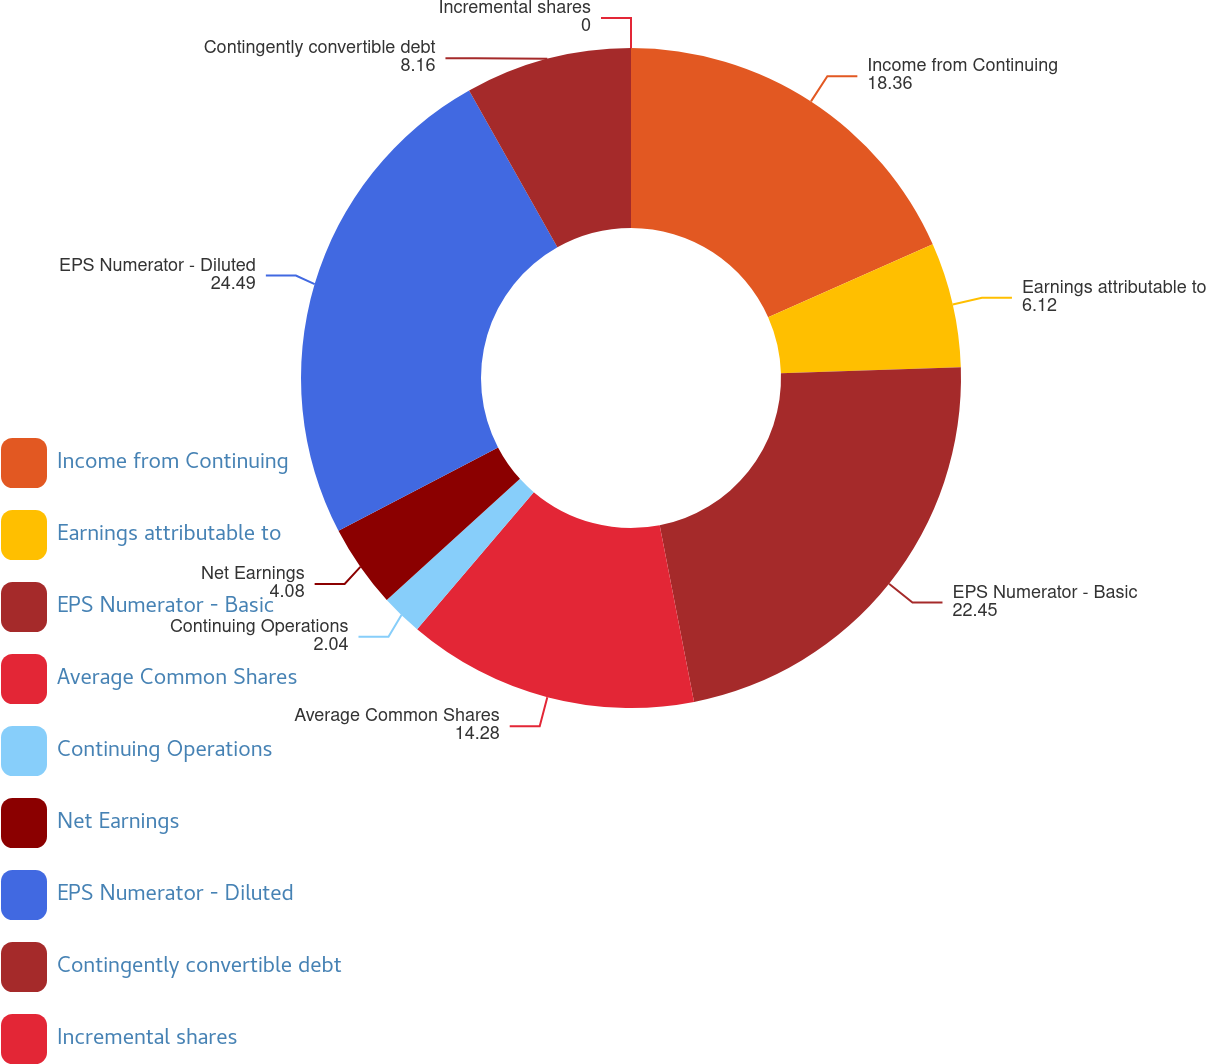Convert chart. <chart><loc_0><loc_0><loc_500><loc_500><pie_chart><fcel>Income from Continuing<fcel>Earnings attributable to<fcel>EPS Numerator - Basic<fcel>Average Common Shares<fcel>Continuing Operations<fcel>Net Earnings<fcel>EPS Numerator - Diluted<fcel>Contingently convertible debt<fcel>Incremental shares<nl><fcel>18.36%<fcel>6.12%<fcel>22.45%<fcel>14.28%<fcel>2.04%<fcel>4.08%<fcel>24.49%<fcel>8.16%<fcel>0.0%<nl></chart> 